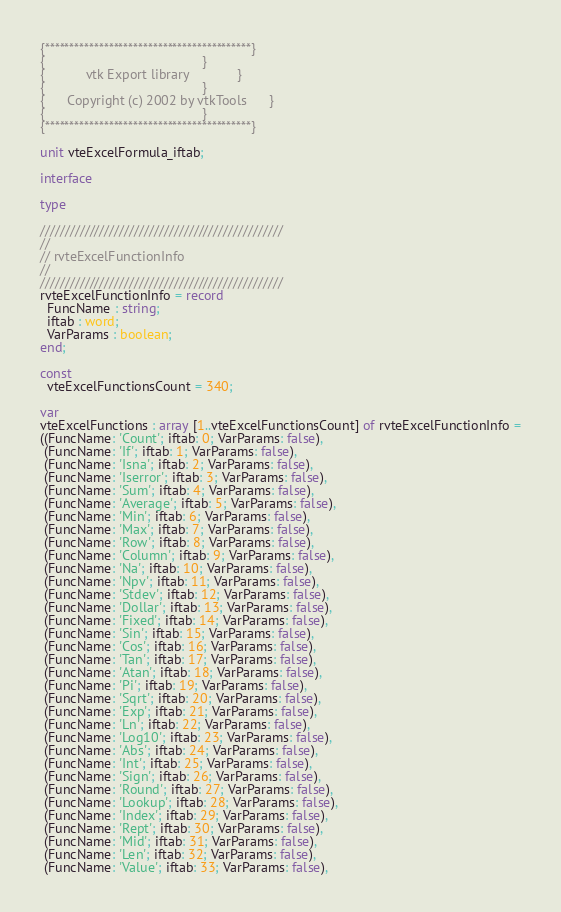<code> <loc_0><loc_0><loc_500><loc_500><_Pascal_>
{******************************************}
{                                          }
{           vtk Export library             }
{                                          }
{      Copyright (c) 2002 by vtkTools      }
{                                          }
{******************************************}

unit vteExcelFormula_iftab;

interface

type

/////////////////////////////////////////////////
//
// rvteExcelFunctionInfo
//
/////////////////////////////////////////////////
rvteExcelFunctionInfo = record
  FuncName : string;
  iftab : word;
  VarParams : boolean;
end;

const
  vteExcelFunctionsCount = 340;

var
vteExcelFunctions : array [1..vteExcelFunctionsCount] of rvteExcelFunctionInfo =
((FuncName: 'Count'; iftab: 0; VarParams: false),
 (FuncName: 'If'; iftab: 1; VarParams: false),
 (FuncName: 'Isna'; iftab: 2; VarParams: false),
 (FuncName: 'Iserror'; iftab: 3; VarParams: false),
 (FuncName: 'Sum'; iftab: 4; VarParams: false),
 (FuncName: 'Average'; iftab: 5; VarParams: false),
 (FuncName: 'Min'; iftab: 6; VarParams: false),
 (FuncName: 'Max'; iftab: 7; VarParams: false),
 (FuncName: 'Row'; iftab: 8; VarParams: false),
 (FuncName: 'Column'; iftab: 9; VarParams: false),
 (FuncName: 'Na'; iftab: 10; VarParams: false),
 (FuncName: 'Npv'; iftab: 11; VarParams: false),
 (FuncName: 'Stdev'; iftab: 12; VarParams: false),
 (FuncName: 'Dollar'; iftab: 13; VarParams: false),
 (FuncName: 'Fixed'; iftab: 14; VarParams: false),
 (FuncName: 'Sin'; iftab: 15; VarParams: false),
 (FuncName: 'Cos'; iftab: 16; VarParams: false),
 (FuncName: 'Tan'; iftab: 17; VarParams: false),
 (FuncName: 'Atan'; iftab: 18; VarParams: false),
 (FuncName: 'Pi'; iftab: 19; VarParams: false),
 (FuncName: 'Sqrt'; iftab: 20; VarParams: false),
 (FuncName: 'Exp'; iftab: 21; VarParams: false),
 (FuncName: 'Ln'; iftab: 22; VarParams: false),
 (FuncName: 'Log10'; iftab: 23; VarParams: false),
 (FuncName: 'Abs'; iftab: 24; VarParams: false),
 (FuncName: 'Int'; iftab: 25; VarParams: false),
 (FuncName: 'Sign'; iftab: 26; VarParams: false),
 (FuncName: 'Round'; iftab: 27; VarParams: false),
 (FuncName: 'Lookup'; iftab: 28; VarParams: false),
 (FuncName: 'Index'; iftab: 29; VarParams: false),
 (FuncName: 'Rept'; iftab: 30; VarParams: false),
 (FuncName: 'Mid'; iftab: 31; VarParams: false),
 (FuncName: 'Len'; iftab: 32; VarParams: false),
 (FuncName: 'Value'; iftab: 33; VarParams: false),</code> 